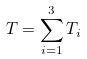<formula> <loc_0><loc_0><loc_500><loc_500>T = \sum _ { i = 1 } ^ { 3 } T _ { i }</formula> 